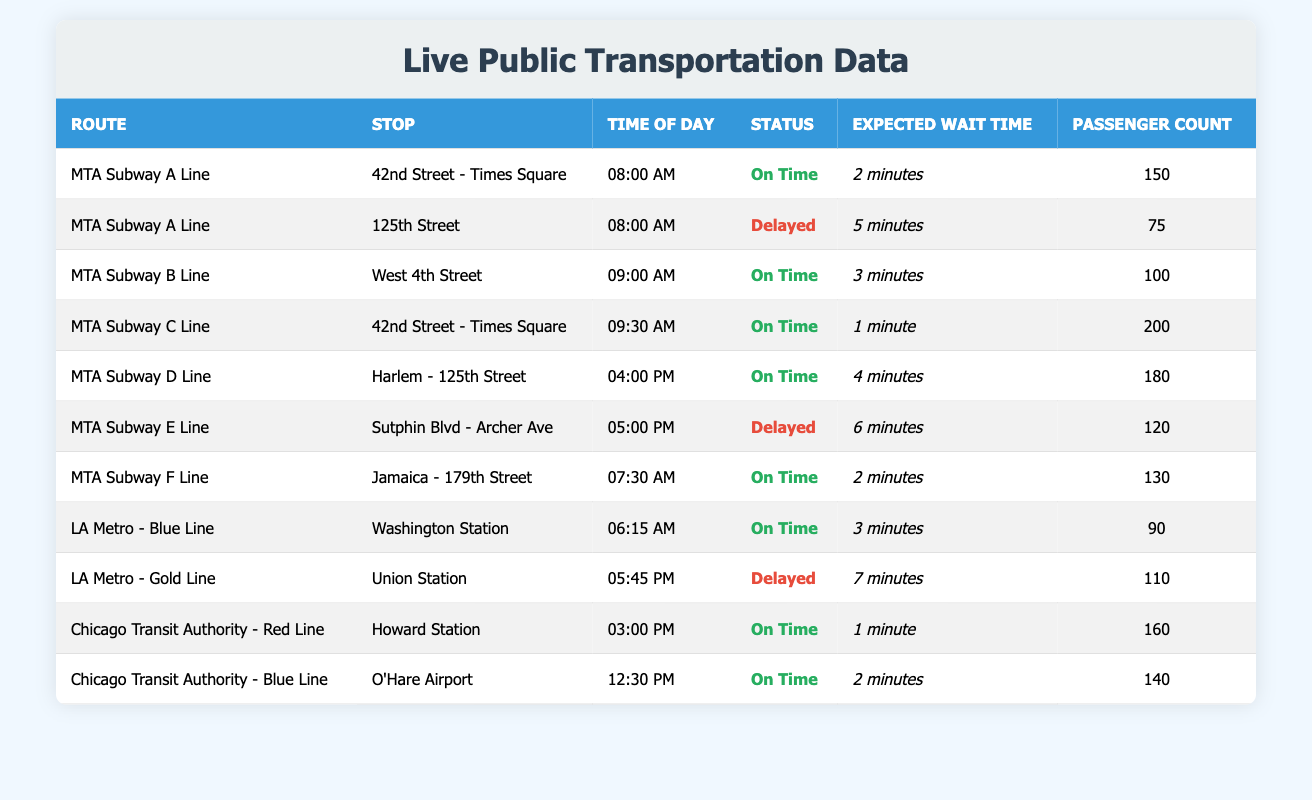What is the status of the MTA Subway A Line at 42nd Street - Times Square? According to the table, the MTA Subway A Line at 42nd Street - Times Square at 08:00 AM is "On Time."
Answer: On Time How many passengers were at the LA Metro - Gold Line stop, Union Station? The table shows that the number of passengers at the LA Metro - Gold Line, Union Station at 05:45 PM is 110.
Answer: 110 Which stop has the longest expected wait time? By reviewing the expected wait times in the table, the MTA Subway E Line at Sutphin Blvd - Archer Ave at 05:00 PM has the longest wait time of 6 minutes.
Answer: 6 minutes How many stops have a status of "Delayed"? The table highlights 3 stops with a "Delayed" status: MTA Subway A Line at 125th Street, MTA Subway E Line at Sutphin Blvd - Archer Ave, and LA Metro - Gold Line at Union Station. Therefore, the answer is 3.
Answer: 3 What is the average passenger count for "On Time" services? To calculate the average, we first identify the passenger counts for "On Time" statuses: 150, 100, 200, 180, 130, 90, 160, and 140. Adding these gives 1,100 total passengers over 8 "On Time" entries, and dividing this by 8 yields an average of 137.5.
Answer: 137.5 Is the MTA Subway C Line always "On Time"? The table presents only one entry for the MTA Subway C Line, which is at 09:30 AM and has a status of "On Time." Since this is the sole entry, we cannot confirm it is "always On Time."
Answer: No What is the total expected wait time across all routes? To find the total expected wait time, we convert all wait times to minutes (2 + 5 + 3 + 1 + 4 + 6 + 2 + 3 + 7 + 1 + 2) which sums to 34 minutes. Thus, the total expected wait time across all routes is 34 minutes.
Answer: 34 minutes How many routes are affected by delays during the 08:00 AM time slot? In the 08:00 AM time slot, we examine two entries for MTA Subway A Line: one is "On Time," while the other at 125th Street is "Delayed." This indicates that 1 route is affected by delays.
Answer: 1 What is the wait time difference between the MTA Subway E Line and MTA Subway B Line? The expected wait time for the MTA Subway E Line at 05:00 PM is 6 minutes, while for the MTA Subway B Line at 09:00 AM, it is 3 minutes. The difference in wait times is 6 - 3 = 3 minutes.
Answer: 3 minutes 